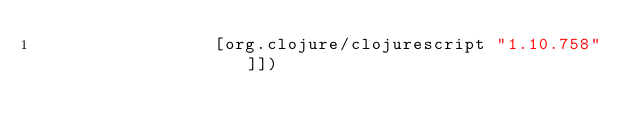Convert code to text. <code><loc_0><loc_0><loc_500><loc_500><_Clojure_>                 [org.clojure/clojurescript "1.10.758"]])
</code> 